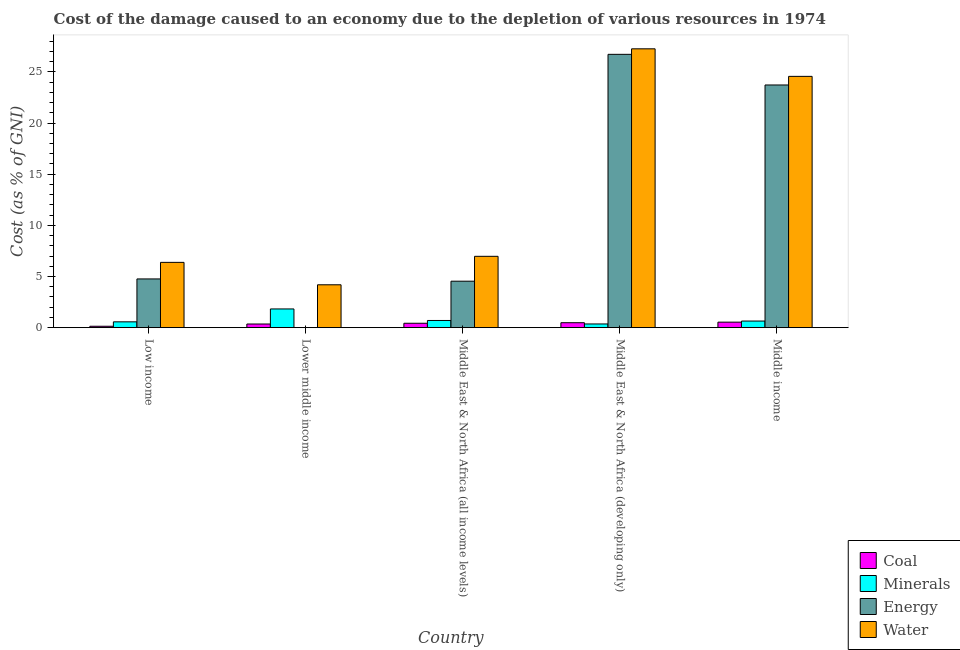Are the number of bars on each tick of the X-axis equal?
Your response must be concise. Yes. How many bars are there on the 4th tick from the left?
Ensure brevity in your answer.  4. What is the cost of damage due to depletion of minerals in Low income?
Give a very brief answer. 0.57. Across all countries, what is the maximum cost of damage due to depletion of coal?
Offer a very short reply. 0.54. Across all countries, what is the minimum cost of damage due to depletion of energy?
Your answer should be very brief. 0.01. In which country was the cost of damage due to depletion of energy minimum?
Give a very brief answer. Lower middle income. What is the total cost of damage due to depletion of energy in the graph?
Keep it short and to the point. 59.76. What is the difference between the cost of damage due to depletion of water in Middle East & North Africa (all income levels) and that in Middle East & North Africa (developing only)?
Ensure brevity in your answer.  -20.28. What is the difference between the cost of damage due to depletion of minerals in Lower middle income and the cost of damage due to depletion of energy in Middle East & North Africa (all income levels)?
Ensure brevity in your answer.  -2.71. What is the average cost of damage due to depletion of water per country?
Your response must be concise. 13.87. What is the difference between the cost of damage due to depletion of coal and cost of damage due to depletion of energy in Middle East & North Africa (developing only)?
Ensure brevity in your answer.  -26.24. In how many countries, is the cost of damage due to depletion of minerals greater than 19 %?
Your answer should be very brief. 0. What is the ratio of the cost of damage due to depletion of coal in Middle East & North Africa (developing only) to that in Middle income?
Your response must be concise. 0.9. Is the difference between the cost of damage due to depletion of water in Lower middle income and Middle East & North Africa (developing only) greater than the difference between the cost of damage due to depletion of energy in Lower middle income and Middle East & North Africa (developing only)?
Your response must be concise. Yes. What is the difference between the highest and the second highest cost of damage due to depletion of minerals?
Your response must be concise. 1.13. What is the difference between the highest and the lowest cost of damage due to depletion of minerals?
Your response must be concise. 1.47. In how many countries, is the cost of damage due to depletion of coal greater than the average cost of damage due to depletion of coal taken over all countries?
Provide a short and direct response. 3. Is the sum of the cost of damage due to depletion of energy in Middle East & North Africa (all income levels) and Middle East & North Africa (developing only) greater than the maximum cost of damage due to depletion of water across all countries?
Ensure brevity in your answer.  Yes. What does the 3rd bar from the left in Middle East & North Africa (all income levels) represents?
Your response must be concise. Energy. What does the 3rd bar from the right in Low income represents?
Provide a short and direct response. Minerals. Are the values on the major ticks of Y-axis written in scientific E-notation?
Make the answer very short. No. Does the graph contain any zero values?
Your response must be concise. No. Does the graph contain grids?
Make the answer very short. No. How many legend labels are there?
Your answer should be very brief. 4. How are the legend labels stacked?
Offer a very short reply. Vertical. What is the title of the graph?
Offer a very short reply. Cost of the damage caused to an economy due to the depletion of various resources in 1974 . Does "Natural Gas" appear as one of the legend labels in the graph?
Offer a terse response. No. What is the label or title of the Y-axis?
Your answer should be compact. Cost (as % of GNI). What is the Cost (as % of GNI) of Coal in Low income?
Your answer should be very brief. 0.14. What is the Cost (as % of GNI) in Minerals in Low income?
Provide a short and direct response. 0.57. What is the Cost (as % of GNI) in Energy in Low income?
Give a very brief answer. 4.76. What is the Cost (as % of GNI) in Water in Low income?
Your response must be concise. 6.38. What is the Cost (as % of GNI) in Coal in Lower middle income?
Your response must be concise. 0.36. What is the Cost (as % of GNI) of Minerals in Lower middle income?
Ensure brevity in your answer.  1.83. What is the Cost (as % of GNI) of Energy in Lower middle income?
Ensure brevity in your answer.  0.01. What is the Cost (as % of GNI) of Water in Lower middle income?
Make the answer very short. 4.19. What is the Cost (as % of GNI) in Coal in Middle East & North Africa (all income levels)?
Your answer should be very brief. 0.43. What is the Cost (as % of GNI) of Minerals in Middle East & North Africa (all income levels)?
Keep it short and to the point. 0.7. What is the Cost (as % of GNI) of Energy in Middle East & North Africa (all income levels)?
Your answer should be compact. 4.54. What is the Cost (as % of GNI) in Water in Middle East & North Africa (all income levels)?
Ensure brevity in your answer.  6.97. What is the Cost (as % of GNI) in Coal in Middle East & North Africa (developing only)?
Make the answer very short. 0.48. What is the Cost (as % of GNI) in Minerals in Middle East & North Africa (developing only)?
Your response must be concise. 0.36. What is the Cost (as % of GNI) of Energy in Middle East & North Africa (developing only)?
Keep it short and to the point. 26.72. What is the Cost (as % of GNI) of Water in Middle East & North Africa (developing only)?
Provide a succinct answer. 27.26. What is the Cost (as % of GNI) in Coal in Middle income?
Provide a short and direct response. 0.54. What is the Cost (as % of GNI) in Minerals in Middle income?
Your response must be concise. 0.65. What is the Cost (as % of GNI) of Energy in Middle income?
Offer a terse response. 23.72. What is the Cost (as % of GNI) in Water in Middle income?
Provide a short and direct response. 24.57. Across all countries, what is the maximum Cost (as % of GNI) in Coal?
Your response must be concise. 0.54. Across all countries, what is the maximum Cost (as % of GNI) in Minerals?
Make the answer very short. 1.83. Across all countries, what is the maximum Cost (as % of GNI) in Energy?
Provide a short and direct response. 26.72. Across all countries, what is the maximum Cost (as % of GNI) in Water?
Your answer should be compact. 27.26. Across all countries, what is the minimum Cost (as % of GNI) of Coal?
Your response must be concise. 0.14. Across all countries, what is the minimum Cost (as % of GNI) in Minerals?
Make the answer very short. 0.36. Across all countries, what is the minimum Cost (as % of GNI) in Energy?
Offer a very short reply. 0.01. Across all countries, what is the minimum Cost (as % of GNI) in Water?
Make the answer very short. 4.19. What is the total Cost (as % of GNI) of Coal in the graph?
Offer a terse response. 1.95. What is the total Cost (as % of GNI) of Minerals in the graph?
Offer a very short reply. 4.11. What is the total Cost (as % of GNI) of Energy in the graph?
Ensure brevity in your answer.  59.76. What is the total Cost (as % of GNI) of Water in the graph?
Offer a terse response. 69.37. What is the difference between the Cost (as % of GNI) in Coal in Low income and that in Lower middle income?
Make the answer very short. -0.22. What is the difference between the Cost (as % of GNI) of Minerals in Low income and that in Lower middle income?
Ensure brevity in your answer.  -1.26. What is the difference between the Cost (as % of GNI) of Energy in Low income and that in Lower middle income?
Your response must be concise. 4.76. What is the difference between the Cost (as % of GNI) of Water in Low income and that in Lower middle income?
Give a very brief answer. 2.19. What is the difference between the Cost (as % of GNI) of Coal in Low income and that in Middle East & North Africa (all income levels)?
Provide a succinct answer. -0.29. What is the difference between the Cost (as % of GNI) in Minerals in Low income and that in Middle East & North Africa (all income levels)?
Give a very brief answer. -0.13. What is the difference between the Cost (as % of GNI) in Energy in Low income and that in Middle East & North Africa (all income levels)?
Offer a terse response. 0.22. What is the difference between the Cost (as % of GNI) in Water in Low income and that in Middle East & North Africa (all income levels)?
Provide a short and direct response. -0.59. What is the difference between the Cost (as % of GNI) in Coal in Low income and that in Middle East & North Africa (developing only)?
Your response must be concise. -0.35. What is the difference between the Cost (as % of GNI) of Minerals in Low income and that in Middle East & North Africa (developing only)?
Offer a terse response. 0.21. What is the difference between the Cost (as % of GNI) of Energy in Low income and that in Middle East & North Africa (developing only)?
Provide a short and direct response. -21.96. What is the difference between the Cost (as % of GNI) in Water in Low income and that in Middle East & North Africa (developing only)?
Your answer should be very brief. -20.88. What is the difference between the Cost (as % of GNI) in Coal in Low income and that in Middle income?
Your answer should be very brief. -0.4. What is the difference between the Cost (as % of GNI) in Minerals in Low income and that in Middle income?
Offer a terse response. -0.08. What is the difference between the Cost (as % of GNI) of Energy in Low income and that in Middle income?
Provide a succinct answer. -18.96. What is the difference between the Cost (as % of GNI) of Water in Low income and that in Middle income?
Provide a succinct answer. -18.18. What is the difference between the Cost (as % of GNI) in Coal in Lower middle income and that in Middle East & North Africa (all income levels)?
Your response must be concise. -0.07. What is the difference between the Cost (as % of GNI) in Minerals in Lower middle income and that in Middle East & North Africa (all income levels)?
Offer a terse response. 1.13. What is the difference between the Cost (as % of GNI) in Energy in Lower middle income and that in Middle East & North Africa (all income levels)?
Offer a terse response. -4.54. What is the difference between the Cost (as % of GNI) in Water in Lower middle income and that in Middle East & North Africa (all income levels)?
Give a very brief answer. -2.78. What is the difference between the Cost (as % of GNI) of Coal in Lower middle income and that in Middle East & North Africa (developing only)?
Offer a very short reply. -0.13. What is the difference between the Cost (as % of GNI) of Minerals in Lower middle income and that in Middle East & North Africa (developing only)?
Give a very brief answer. 1.47. What is the difference between the Cost (as % of GNI) in Energy in Lower middle income and that in Middle East & North Africa (developing only)?
Give a very brief answer. -26.71. What is the difference between the Cost (as % of GNI) in Water in Lower middle income and that in Middle East & North Africa (developing only)?
Your answer should be very brief. -23.07. What is the difference between the Cost (as % of GNI) in Coal in Lower middle income and that in Middle income?
Give a very brief answer. -0.18. What is the difference between the Cost (as % of GNI) of Minerals in Lower middle income and that in Middle income?
Your response must be concise. 1.18. What is the difference between the Cost (as % of GNI) of Energy in Lower middle income and that in Middle income?
Provide a succinct answer. -23.72. What is the difference between the Cost (as % of GNI) in Water in Lower middle income and that in Middle income?
Offer a very short reply. -20.37. What is the difference between the Cost (as % of GNI) in Coal in Middle East & North Africa (all income levels) and that in Middle East & North Africa (developing only)?
Your answer should be very brief. -0.05. What is the difference between the Cost (as % of GNI) in Minerals in Middle East & North Africa (all income levels) and that in Middle East & North Africa (developing only)?
Ensure brevity in your answer.  0.34. What is the difference between the Cost (as % of GNI) in Energy in Middle East & North Africa (all income levels) and that in Middle East & North Africa (developing only)?
Your answer should be very brief. -22.18. What is the difference between the Cost (as % of GNI) of Water in Middle East & North Africa (all income levels) and that in Middle East & North Africa (developing only)?
Give a very brief answer. -20.28. What is the difference between the Cost (as % of GNI) of Coal in Middle East & North Africa (all income levels) and that in Middle income?
Offer a very short reply. -0.11. What is the difference between the Cost (as % of GNI) of Minerals in Middle East & North Africa (all income levels) and that in Middle income?
Offer a terse response. 0.06. What is the difference between the Cost (as % of GNI) in Energy in Middle East & North Africa (all income levels) and that in Middle income?
Provide a short and direct response. -19.18. What is the difference between the Cost (as % of GNI) in Water in Middle East & North Africa (all income levels) and that in Middle income?
Provide a succinct answer. -17.59. What is the difference between the Cost (as % of GNI) in Coal in Middle East & North Africa (developing only) and that in Middle income?
Make the answer very short. -0.06. What is the difference between the Cost (as % of GNI) of Minerals in Middle East & North Africa (developing only) and that in Middle income?
Your answer should be compact. -0.28. What is the difference between the Cost (as % of GNI) of Energy in Middle East & North Africa (developing only) and that in Middle income?
Your response must be concise. 3. What is the difference between the Cost (as % of GNI) in Water in Middle East & North Africa (developing only) and that in Middle income?
Make the answer very short. 2.69. What is the difference between the Cost (as % of GNI) of Coal in Low income and the Cost (as % of GNI) of Minerals in Lower middle income?
Provide a short and direct response. -1.69. What is the difference between the Cost (as % of GNI) of Coal in Low income and the Cost (as % of GNI) of Energy in Lower middle income?
Your response must be concise. 0.13. What is the difference between the Cost (as % of GNI) in Coal in Low income and the Cost (as % of GNI) in Water in Lower middle income?
Provide a short and direct response. -4.05. What is the difference between the Cost (as % of GNI) in Minerals in Low income and the Cost (as % of GNI) in Energy in Lower middle income?
Ensure brevity in your answer.  0.56. What is the difference between the Cost (as % of GNI) in Minerals in Low income and the Cost (as % of GNI) in Water in Lower middle income?
Offer a very short reply. -3.62. What is the difference between the Cost (as % of GNI) in Energy in Low income and the Cost (as % of GNI) in Water in Lower middle income?
Keep it short and to the point. 0.57. What is the difference between the Cost (as % of GNI) of Coal in Low income and the Cost (as % of GNI) of Minerals in Middle East & North Africa (all income levels)?
Your answer should be compact. -0.57. What is the difference between the Cost (as % of GNI) in Coal in Low income and the Cost (as % of GNI) in Energy in Middle East & North Africa (all income levels)?
Give a very brief answer. -4.41. What is the difference between the Cost (as % of GNI) in Coal in Low income and the Cost (as % of GNI) in Water in Middle East & North Africa (all income levels)?
Your response must be concise. -6.84. What is the difference between the Cost (as % of GNI) in Minerals in Low income and the Cost (as % of GNI) in Energy in Middle East & North Africa (all income levels)?
Your answer should be very brief. -3.97. What is the difference between the Cost (as % of GNI) of Minerals in Low income and the Cost (as % of GNI) of Water in Middle East & North Africa (all income levels)?
Give a very brief answer. -6.4. What is the difference between the Cost (as % of GNI) in Energy in Low income and the Cost (as % of GNI) in Water in Middle East & North Africa (all income levels)?
Offer a very short reply. -2.21. What is the difference between the Cost (as % of GNI) in Coal in Low income and the Cost (as % of GNI) in Minerals in Middle East & North Africa (developing only)?
Your answer should be very brief. -0.22. What is the difference between the Cost (as % of GNI) of Coal in Low income and the Cost (as % of GNI) of Energy in Middle East & North Africa (developing only)?
Offer a very short reply. -26.58. What is the difference between the Cost (as % of GNI) in Coal in Low income and the Cost (as % of GNI) in Water in Middle East & North Africa (developing only)?
Offer a very short reply. -27.12. What is the difference between the Cost (as % of GNI) in Minerals in Low income and the Cost (as % of GNI) in Energy in Middle East & North Africa (developing only)?
Offer a terse response. -26.15. What is the difference between the Cost (as % of GNI) in Minerals in Low income and the Cost (as % of GNI) in Water in Middle East & North Africa (developing only)?
Your response must be concise. -26.69. What is the difference between the Cost (as % of GNI) of Energy in Low income and the Cost (as % of GNI) of Water in Middle East & North Africa (developing only)?
Your answer should be compact. -22.5. What is the difference between the Cost (as % of GNI) of Coal in Low income and the Cost (as % of GNI) of Minerals in Middle income?
Provide a succinct answer. -0.51. What is the difference between the Cost (as % of GNI) in Coal in Low income and the Cost (as % of GNI) in Energy in Middle income?
Keep it short and to the point. -23.59. What is the difference between the Cost (as % of GNI) of Coal in Low income and the Cost (as % of GNI) of Water in Middle income?
Provide a succinct answer. -24.43. What is the difference between the Cost (as % of GNI) in Minerals in Low income and the Cost (as % of GNI) in Energy in Middle income?
Offer a very short reply. -23.15. What is the difference between the Cost (as % of GNI) of Minerals in Low income and the Cost (as % of GNI) of Water in Middle income?
Your answer should be compact. -24. What is the difference between the Cost (as % of GNI) of Energy in Low income and the Cost (as % of GNI) of Water in Middle income?
Make the answer very short. -19.8. What is the difference between the Cost (as % of GNI) of Coal in Lower middle income and the Cost (as % of GNI) of Minerals in Middle East & North Africa (all income levels)?
Provide a short and direct response. -0.34. What is the difference between the Cost (as % of GNI) of Coal in Lower middle income and the Cost (as % of GNI) of Energy in Middle East & North Africa (all income levels)?
Provide a short and direct response. -4.18. What is the difference between the Cost (as % of GNI) in Coal in Lower middle income and the Cost (as % of GNI) in Water in Middle East & North Africa (all income levels)?
Your answer should be very brief. -6.62. What is the difference between the Cost (as % of GNI) of Minerals in Lower middle income and the Cost (as % of GNI) of Energy in Middle East & North Africa (all income levels)?
Your response must be concise. -2.71. What is the difference between the Cost (as % of GNI) of Minerals in Lower middle income and the Cost (as % of GNI) of Water in Middle East & North Africa (all income levels)?
Offer a very short reply. -5.15. What is the difference between the Cost (as % of GNI) of Energy in Lower middle income and the Cost (as % of GNI) of Water in Middle East & North Africa (all income levels)?
Your answer should be very brief. -6.97. What is the difference between the Cost (as % of GNI) in Coal in Lower middle income and the Cost (as % of GNI) in Minerals in Middle East & North Africa (developing only)?
Provide a succinct answer. -0. What is the difference between the Cost (as % of GNI) of Coal in Lower middle income and the Cost (as % of GNI) of Energy in Middle East & North Africa (developing only)?
Give a very brief answer. -26.36. What is the difference between the Cost (as % of GNI) of Coal in Lower middle income and the Cost (as % of GNI) of Water in Middle East & North Africa (developing only)?
Provide a short and direct response. -26.9. What is the difference between the Cost (as % of GNI) in Minerals in Lower middle income and the Cost (as % of GNI) in Energy in Middle East & North Africa (developing only)?
Your answer should be compact. -24.89. What is the difference between the Cost (as % of GNI) of Minerals in Lower middle income and the Cost (as % of GNI) of Water in Middle East & North Africa (developing only)?
Offer a terse response. -25.43. What is the difference between the Cost (as % of GNI) in Energy in Lower middle income and the Cost (as % of GNI) in Water in Middle East & North Africa (developing only)?
Ensure brevity in your answer.  -27.25. What is the difference between the Cost (as % of GNI) in Coal in Lower middle income and the Cost (as % of GNI) in Minerals in Middle income?
Your response must be concise. -0.29. What is the difference between the Cost (as % of GNI) in Coal in Lower middle income and the Cost (as % of GNI) in Energy in Middle income?
Give a very brief answer. -23.37. What is the difference between the Cost (as % of GNI) of Coal in Lower middle income and the Cost (as % of GNI) of Water in Middle income?
Provide a short and direct response. -24.21. What is the difference between the Cost (as % of GNI) in Minerals in Lower middle income and the Cost (as % of GNI) in Energy in Middle income?
Your answer should be compact. -21.9. What is the difference between the Cost (as % of GNI) of Minerals in Lower middle income and the Cost (as % of GNI) of Water in Middle income?
Ensure brevity in your answer.  -22.74. What is the difference between the Cost (as % of GNI) in Energy in Lower middle income and the Cost (as % of GNI) in Water in Middle income?
Your answer should be very brief. -24.56. What is the difference between the Cost (as % of GNI) in Coal in Middle East & North Africa (all income levels) and the Cost (as % of GNI) in Minerals in Middle East & North Africa (developing only)?
Provide a short and direct response. 0.07. What is the difference between the Cost (as % of GNI) of Coal in Middle East & North Africa (all income levels) and the Cost (as % of GNI) of Energy in Middle East & North Africa (developing only)?
Your answer should be very brief. -26.29. What is the difference between the Cost (as % of GNI) of Coal in Middle East & North Africa (all income levels) and the Cost (as % of GNI) of Water in Middle East & North Africa (developing only)?
Your answer should be very brief. -26.83. What is the difference between the Cost (as % of GNI) of Minerals in Middle East & North Africa (all income levels) and the Cost (as % of GNI) of Energy in Middle East & North Africa (developing only)?
Give a very brief answer. -26.02. What is the difference between the Cost (as % of GNI) in Minerals in Middle East & North Africa (all income levels) and the Cost (as % of GNI) in Water in Middle East & North Africa (developing only)?
Provide a succinct answer. -26.56. What is the difference between the Cost (as % of GNI) of Energy in Middle East & North Africa (all income levels) and the Cost (as % of GNI) of Water in Middle East & North Africa (developing only)?
Provide a short and direct response. -22.72. What is the difference between the Cost (as % of GNI) in Coal in Middle East & North Africa (all income levels) and the Cost (as % of GNI) in Minerals in Middle income?
Ensure brevity in your answer.  -0.21. What is the difference between the Cost (as % of GNI) in Coal in Middle East & North Africa (all income levels) and the Cost (as % of GNI) in Energy in Middle income?
Give a very brief answer. -23.29. What is the difference between the Cost (as % of GNI) of Coal in Middle East & North Africa (all income levels) and the Cost (as % of GNI) of Water in Middle income?
Provide a short and direct response. -24.13. What is the difference between the Cost (as % of GNI) of Minerals in Middle East & North Africa (all income levels) and the Cost (as % of GNI) of Energy in Middle income?
Offer a very short reply. -23.02. What is the difference between the Cost (as % of GNI) in Minerals in Middle East & North Africa (all income levels) and the Cost (as % of GNI) in Water in Middle income?
Your answer should be compact. -23.86. What is the difference between the Cost (as % of GNI) of Energy in Middle East & North Africa (all income levels) and the Cost (as % of GNI) of Water in Middle income?
Give a very brief answer. -20.02. What is the difference between the Cost (as % of GNI) of Coal in Middle East & North Africa (developing only) and the Cost (as % of GNI) of Minerals in Middle income?
Your answer should be compact. -0.16. What is the difference between the Cost (as % of GNI) in Coal in Middle East & North Africa (developing only) and the Cost (as % of GNI) in Energy in Middle income?
Your answer should be very brief. -23.24. What is the difference between the Cost (as % of GNI) of Coal in Middle East & North Africa (developing only) and the Cost (as % of GNI) of Water in Middle income?
Your answer should be compact. -24.08. What is the difference between the Cost (as % of GNI) of Minerals in Middle East & North Africa (developing only) and the Cost (as % of GNI) of Energy in Middle income?
Offer a very short reply. -23.36. What is the difference between the Cost (as % of GNI) in Minerals in Middle East & North Africa (developing only) and the Cost (as % of GNI) in Water in Middle income?
Provide a succinct answer. -24.2. What is the difference between the Cost (as % of GNI) in Energy in Middle East & North Africa (developing only) and the Cost (as % of GNI) in Water in Middle income?
Provide a short and direct response. 2.15. What is the average Cost (as % of GNI) of Coal per country?
Ensure brevity in your answer.  0.39. What is the average Cost (as % of GNI) in Minerals per country?
Give a very brief answer. 0.82. What is the average Cost (as % of GNI) of Energy per country?
Ensure brevity in your answer.  11.95. What is the average Cost (as % of GNI) of Water per country?
Offer a terse response. 13.87. What is the difference between the Cost (as % of GNI) of Coal and Cost (as % of GNI) of Minerals in Low income?
Provide a short and direct response. -0.43. What is the difference between the Cost (as % of GNI) in Coal and Cost (as % of GNI) in Energy in Low income?
Offer a terse response. -4.63. What is the difference between the Cost (as % of GNI) in Coal and Cost (as % of GNI) in Water in Low income?
Ensure brevity in your answer.  -6.25. What is the difference between the Cost (as % of GNI) of Minerals and Cost (as % of GNI) of Energy in Low income?
Your answer should be compact. -4.19. What is the difference between the Cost (as % of GNI) in Minerals and Cost (as % of GNI) in Water in Low income?
Provide a short and direct response. -5.81. What is the difference between the Cost (as % of GNI) in Energy and Cost (as % of GNI) in Water in Low income?
Give a very brief answer. -1.62. What is the difference between the Cost (as % of GNI) in Coal and Cost (as % of GNI) in Minerals in Lower middle income?
Make the answer very short. -1.47. What is the difference between the Cost (as % of GNI) in Coal and Cost (as % of GNI) in Energy in Lower middle income?
Ensure brevity in your answer.  0.35. What is the difference between the Cost (as % of GNI) in Coal and Cost (as % of GNI) in Water in Lower middle income?
Offer a terse response. -3.83. What is the difference between the Cost (as % of GNI) of Minerals and Cost (as % of GNI) of Energy in Lower middle income?
Provide a succinct answer. 1.82. What is the difference between the Cost (as % of GNI) of Minerals and Cost (as % of GNI) of Water in Lower middle income?
Offer a terse response. -2.36. What is the difference between the Cost (as % of GNI) in Energy and Cost (as % of GNI) in Water in Lower middle income?
Ensure brevity in your answer.  -4.19. What is the difference between the Cost (as % of GNI) of Coal and Cost (as % of GNI) of Minerals in Middle East & North Africa (all income levels)?
Your response must be concise. -0.27. What is the difference between the Cost (as % of GNI) of Coal and Cost (as % of GNI) of Energy in Middle East & North Africa (all income levels)?
Your response must be concise. -4.11. What is the difference between the Cost (as % of GNI) of Coal and Cost (as % of GNI) of Water in Middle East & North Africa (all income levels)?
Keep it short and to the point. -6.54. What is the difference between the Cost (as % of GNI) of Minerals and Cost (as % of GNI) of Energy in Middle East & North Africa (all income levels)?
Keep it short and to the point. -3.84. What is the difference between the Cost (as % of GNI) of Minerals and Cost (as % of GNI) of Water in Middle East & North Africa (all income levels)?
Offer a terse response. -6.27. What is the difference between the Cost (as % of GNI) of Energy and Cost (as % of GNI) of Water in Middle East & North Africa (all income levels)?
Your answer should be very brief. -2.43. What is the difference between the Cost (as % of GNI) in Coal and Cost (as % of GNI) in Minerals in Middle East & North Africa (developing only)?
Provide a short and direct response. 0.12. What is the difference between the Cost (as % of GNI) in Coal and Cost (as % of GNI) in Energy in Middle East & North Africa (developing only)?
Ensure brevity in your answer.  -26.24. What is the difference between the Cost (as % of GNI) of Coal and Cost (as % of GNI) of Water in Middle East & North Africa (developing only)?
Keep it short and to the point. -26.77. What is the difference between the Cost (as % of GNI) in Minerals and Cost (as % of GNI) in Energy in Middle East & North Africa (developing only)?
Keep it short and to the point. -26.36. What is the difference between the Cost (as % of GNI) of Minerals and Cost (as % of GNI) of Water in Middle East & North Africa (developing only)?
Keep it short and to the point. -26.9. What is the difference between the Cost (as % of GNI) of Energy and Cost (as % of GNI) of Water in Middle East & North Africa (developing only)?
Ensure brevity in your answer.  -0.54. What is the difference between the Cost (as % of GNI) of Coal and Cost (as % of GNI) of Minerals in Middle income?
Ensure brevity in your answer.  -0.11. What is the difference between the Cost (as % of GNI) of Coal and Cost (as % of GNI) of Energy in Middle income?
Ensure brevity in your answer.  -23.18. What is the difference between the Cost (as % of GNI) in Coal and Cost (as % of GNI) in Water in Middle income?
Offer a terse response. -24.03. What is the difference between the Cost (as % of GNI) in Minerals and Cost (as % of GNI) in Energy in Middle income?
Your response must be concise. -23.08. What is the difference between the Cost (as % of GNI) of Minerals and Cost (as % of GNI) of Water in Middle income?
Your response must be concise. -23.92. What is the difference between the Cost (as % of GNI) of Energy and Cost (as % of GNI) of Water in Middle income?
Ensure brevity in your answer.  -0.84. What is the ratio of the Cost (as % of GNI) of Coal in Low income to that in Lower middle income?
Your answer should be compact. 0.38. What is the ratio of the Cost (as % of GNI) in Minerals in Low income to that in Lower middle income?
Ensure brevity in your answer.  0.31. What is the ratio of the Cost (as % of GNI) in Energy in Low income to that in Lower middle income?
Your answer should be compact. 818.6. What is the ratio of the Cost (as % of GNI) in Water in Low income to that in Lower middle income?
Offer a very short reply. 1.52. What is the ratio of the Cost (as % of GNI) of Coal in Low income to that in Middle East & North Africa (all income levels)?
Keep it short and to the point. 0.32. What is the ratio of the Cost (as % of GNI) of Minerals in Low income to that in Middle East & North Africa (all income levels)?
Provide a short and direct response. 0.81. What is the ratio of the Cost (as % of GNI) in Energy in Low income to that in Middle East & North Africa (all income levels)?
Offer a terse response. 1.05. What is the ratio of the Cost (as % of GNI) of Water in Low income to that in Middle East & North Africa (all income levels)?
Your response must be concise. 0.92. What is the ratio of the Cost (as % of GNI) in Coal in Low income to that in Middle East & North Africa (developing only)?
Give a very brief answer. 0.28. What is the ratio of the Cost (as % of GNI) in Minerals in Low income to that in Middle East & North Africa (developing only)?
Your answer should be very brief. 1.58. What is the ratio of the Cost (as % of GNI) of Energy in Low income to that in Middle East & North Africa (developing only)?
Provide a succinct answer. 0.18. What is the ratio of the Cost (as % of GNI) in Water in Low income to that in Middle East & North Africa (developing only)?
Provide a short and direct response. 0.23. What is the ratio of the Cost (as % of GNI) of Coal in Low income to that in Middle income?
Ensure brevity in your answer.  0.25. What is the ratio of the Cost (as % of GNI) in Minerals in Low income to that in Middle income?
Ensure brevity in your answer.  0.88. What is the ratio of the Cost (as % of GNI) in Energy in Low income to that in Middle income?
Your answer should be very brief. 0.2. What is the ratio of the Cost (as % of GNI) of Water in Low income to that in Middle income?
Your answer should be very brief. 0.26. What is the ratio of the Cost (as % of GNI) in Coal in Lower middle income to that in Middle East & North Africa (all income levels)?
Offer a terse response. 0.83. What is the ratio of the Cost (as % of GNI) in Minerals in Lower middle income to that in Middle East & North Africa (all income levels)?
Ensure brevity in your answer.  2.6. What is the ratio of the Cost (as % of GNI) of Energy in Lower middle income to that in Middle East & North Africa (all income levels)?
Offer a very short reply. 0. What is the ratio of the Cost (as % of GNI) of Water in Lower middle income to that in Middle East & North Africa (all income levels)?
Offer a terse response. 0.6. What is the ratio of the Cost (as % of GNI) of Coal in Lower middle income to that in Middle East & North Africa (developing only)?
Your answer should be very brief. 0.74. What is the ratio of the Cost (as % of GNI) of Minerals in Lower middle income to that in Middle East & North Africa (developing only)?
Your answer should be compact. 5.05. What is the ratio of the Cost (as % of GNI) of Energy in Lower middle income to that in Middle East & North Africa (developing only)?
Make the answer very short. 0. What is the ratio of the Cost (as % of GNI) of Water in Lower middle income to that in Middle East & North Africa (developing only)?
Provide a short and direct response. 0.15. What is the ratio of the Cost (as % of GNI) of Coal in Lower middle income to that in Middle income?
Your answer should be compact. 0.66. What is the ratio of the Cost (as % of GNI) of Minerals in Lower middle income to that in Middle income?
Your response must be concise. 2.83. What is the ratio of the Cost (as % of GNI) of Energy in Lower middle income to that in Middle income?
Make the answer very short. 0. What is the ratio of the Cost (as % of GNI) of Water in Lower middle income to that in Middle income?
Your answer should be very brief. 0.17. What is the ratio of the Cost (as % of GNI) of Coal in Middle East & North Africa (all income levels) to that in Middle East & North Africa (developing only)?
Make the answer very short. 0.89. What is the ratio of the Cost (as % of GNI) in Minerals in Middle East & North Africa (all income levels) to that in Middle East & North Africa (developing only)?
Offer a terse response. 1.94. What is the ratio of the Cost (as % of GNI) of Energy in Middle East & North Africa (all income levels) to that in Middle East & North Africa (developing only)?
Keep it short and to the point. 0.17. What is the ratio of the Cost (as % of GNI) in Water in Middle East & North Africa (all income levels) to that in Middle East & North Africa (developing only)?
Your answer should be very brief. 0.26. What is the ratio of the Cost (as % of GNI) of Coal in Middle East & North Africa (all income levels) to that in Middle income?
Offer a terse response. 0.8. What is the ratio of the Cost (as % of GNI) in Minerals in Middle East & North Africa (all income levels) to that in Middle income?
Ensure brevity in your answer.  1.09. What is the ratio of the Cost (as % of GNI) in Energy in Middle East & North Africa (all income levels) to that in Middle income?
Offer a terse response. 0.19. What is the ratio of the Cost (as % of GNI) of Water in Middle East & North Africa (all income levels) to that in Middle income?
Provide a short and direct response. 0.28. What is the ratio of the Cost (as % of GNI) of Coal in Middle East & North Africa (developing only) to that in Middle income?
Give a very brief answer. 0.9. What is the ratio of the Cost (as % of GNI) in Minerals in Middle East & North Africa (developing only) to that in Middle income?
Your response must be concise. 0.56. What is the ratio of the Cost (as % of GNI) in Energy in Middle East & North Africa (developing only) to that in Middle income?
Keep it short and to the point. 1.13. What is the ratio of the Cost (as % of GNI) in Water in Middle East & North Africa (developing only) to that in Middle income?
Provide a short and direct response. 1.11. What is the difference between the highest and the second highest Cost (as % of GNI) of Coal?
Your answer should be very brief. 0.06. What is the difference between the highest and the second highest Cost (as % of GNI) in Minerals?
Your answer should be very brief. 1.13. What is the difference between the highest and the second highest Cost (as % of GNI) in Energy?
Offer a terse response. 3. What is the difference between the highest and the second highest Cost (as % of GNI) in Water?
Offer a very short reply. 2.69. What is the difference between the highest and the lowest Cost (as % of GNI) in Coal?
Your response must be concise. 0.4. What is the difference between the highest and the lowest Cost (as % of GNI) in Minerals?
Ensure brevity in your answer.  1.47. What is the difference between the highest and the lowest Cost (as % of GNI) in Energy?
Your answer should be compact. 26.71. What is the difference between the highest and the lowest Cost (as % of GNI) of Water?
Your answer should be compact. 23.07. 